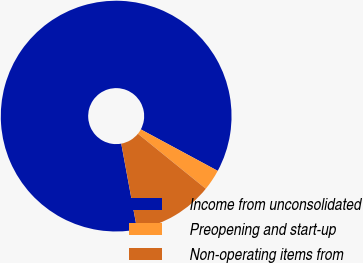<chart> <loc_0><loc_0><loc_500><loc_500><pie_chart><fcel>Income from unconsolidated<fcel>Preopening and start-up<fcel>Non-operating items from<nl><fcel>85.77%<fcel>2.97%<fcel>11.25%<nl></chart> 